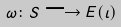<formula> <loc_0><loc_0><loc_500><loc_500>\omega \colon S \longrightarrow E ( \iota )</formula> 